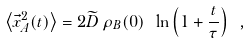<formula> <loc_0><loc_0><loc_500><loc_500>\left \langle \vec { x } _ { A } ^ { 2 } ( t ) \right \rangle = 2 \widetilde { D } \, \rho _ { B } ( 0 ) \ \ln \left ( 1 + \frac { t } { \tau } \right ) \ ,</formula> 